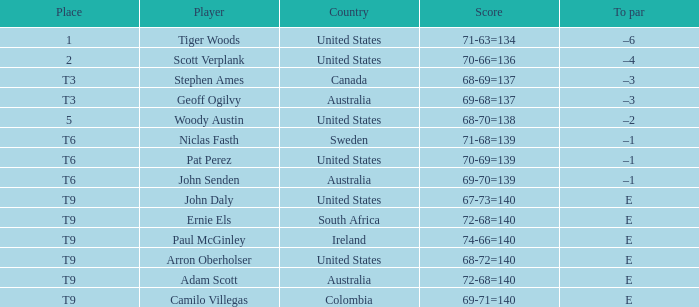Which country has a score of 70-66=136? United States. 